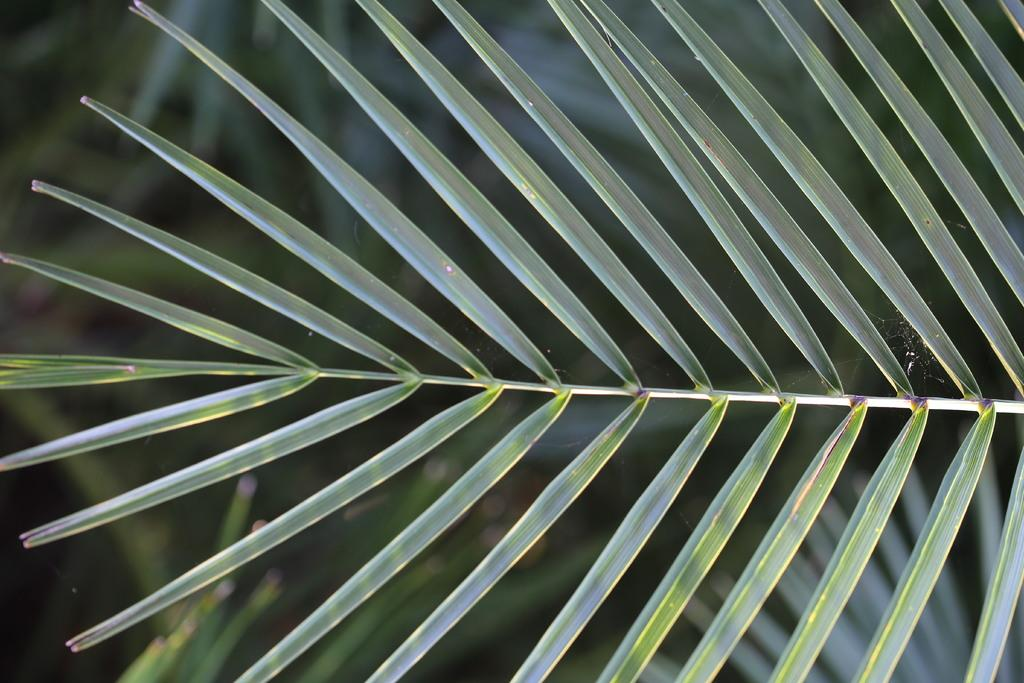What is present in the picture? There is a plant in the picture. Can you describe the plant's appearance? The plant has tall leaves. Are there any other plants or leaves visible in the picture? There are leaves visible behind the plant, but they are not clearly visible. What type of lamp is hanging above the plant in the image? There is no lamp present in the image; it only features a plant with tall leaves and some background leaves. 